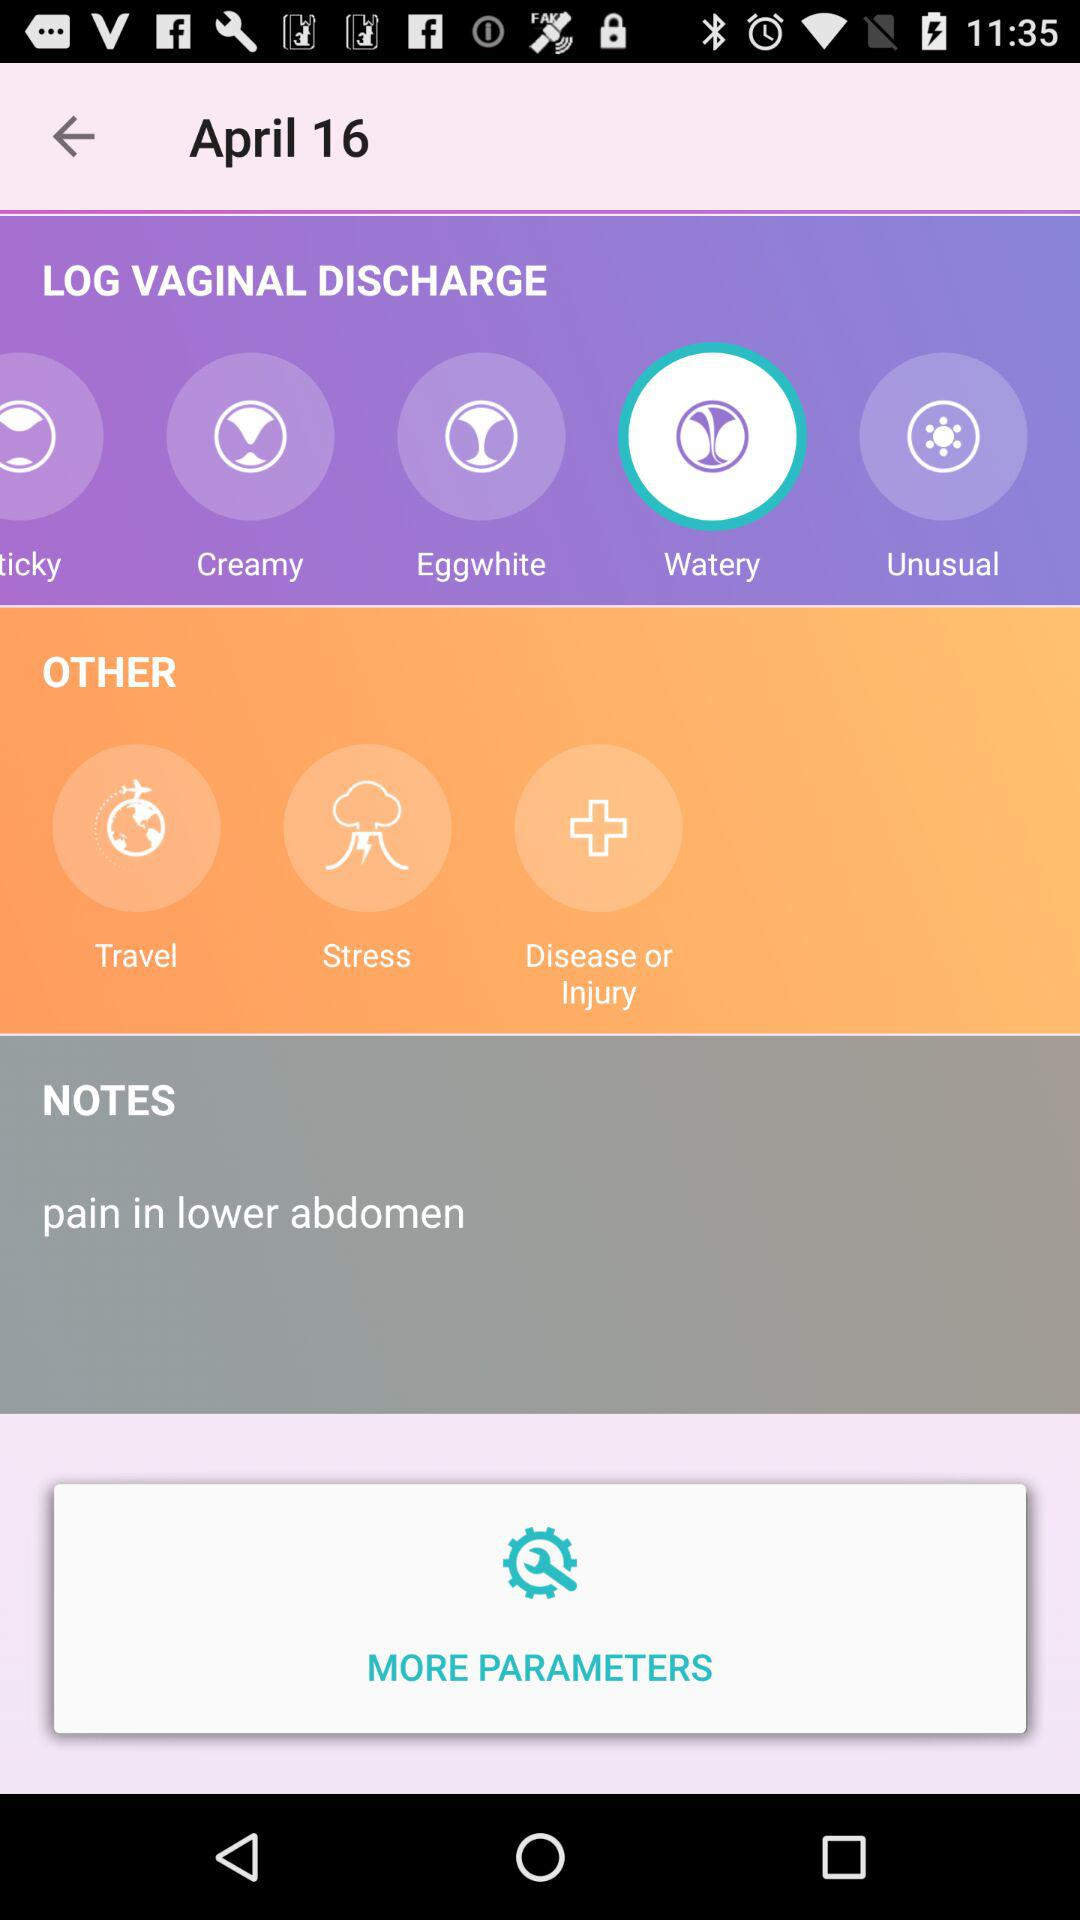How many other possible options are there besides discharge types?
Answer the question using a single word or phrase. 3 